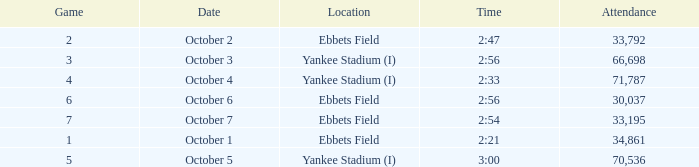Yankee stadium (i), and a time of 3:00 has what attendance for this location? 70536.0. 